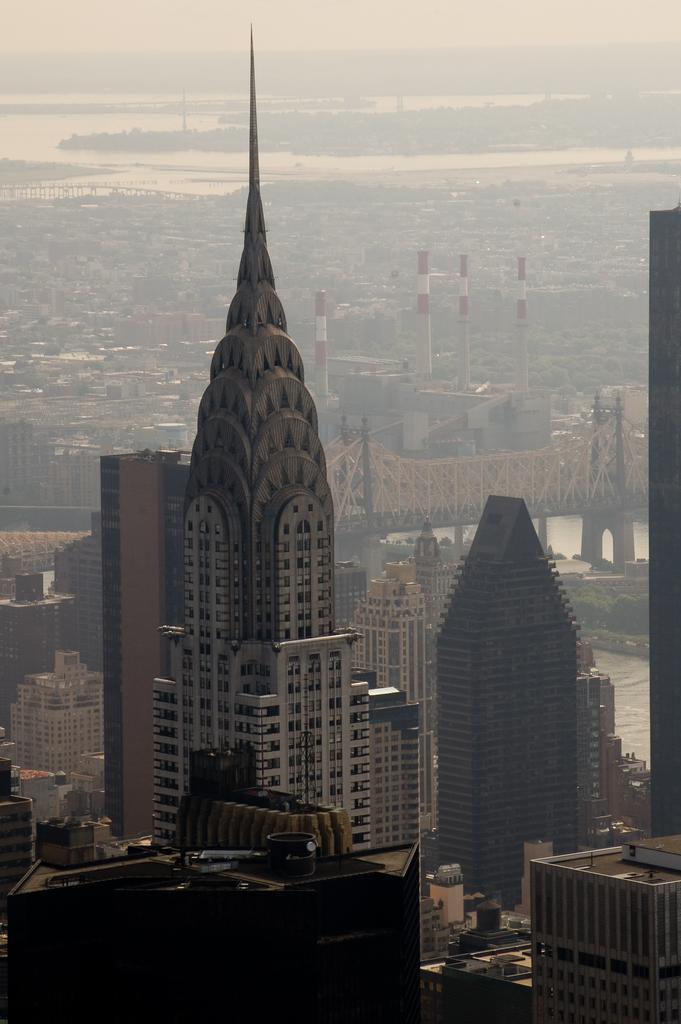In one or two sentences, can you explain what this image depicts? In this image there are buildings, there is bridged, there are towre´is, there is river, there is sky. 